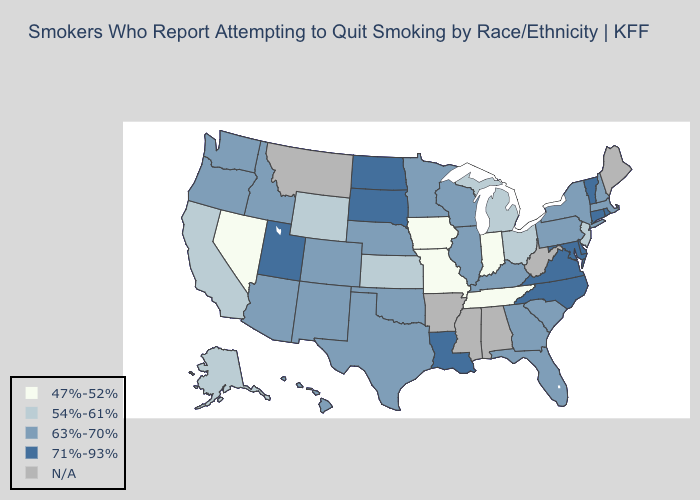Which states have the lowest value in the South?
Short answer required. Tennessee. What is the value of California?
Keep it brief. 54%-61%. What is the lowest value in the USA?
Short answer required. 47%-52%. What is the highest value in states that border Illinois?
Answer briefly. 63%-70%. Which states have the lowest value in the Northeast?
Quick response, please. New Jersey. Which states have the highest value in the USA?
Short answer required. Connecticut, Delaware, Louisiana, Maryland, North Carolina, North Dakota, Rhode Island, South Dakota, Utah, Vermont, Virginia. How many symbols are there in the legend?
Be succinct. 5. What is the value of Idaho?
Be succinct. 63%-70%. Which states have the highest value in the USA?
Quick response, please. Connecticut, Delaware, Louisiana, Maryland, North Carolina, North Dakota, Rhode Island, South Dakota, Utah, Vermont, Virginia. What is the value of Mississippi?
Concise answer only. N/A. What is the value of Hawaii?
Be succinct. 63%-70%. What is the lowest value in the USA?
Give a very brief answer. 47%-52%. Does the map have missing data?
Give a very brief answer. Yes. How many symbols are there in the legend?
Quick response, please. 5. What is the highest value in states that border Tennessee?
Short answer required. 71%-93%. 